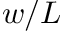<formula> <loc_0><loc_0><loc_500><loc_500>w / L</formula> 